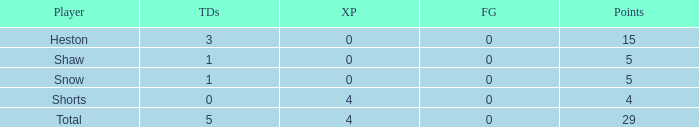What is the sum of all the touchdowns when the player had more than 0 extra points and less than 0 field goals? None. 